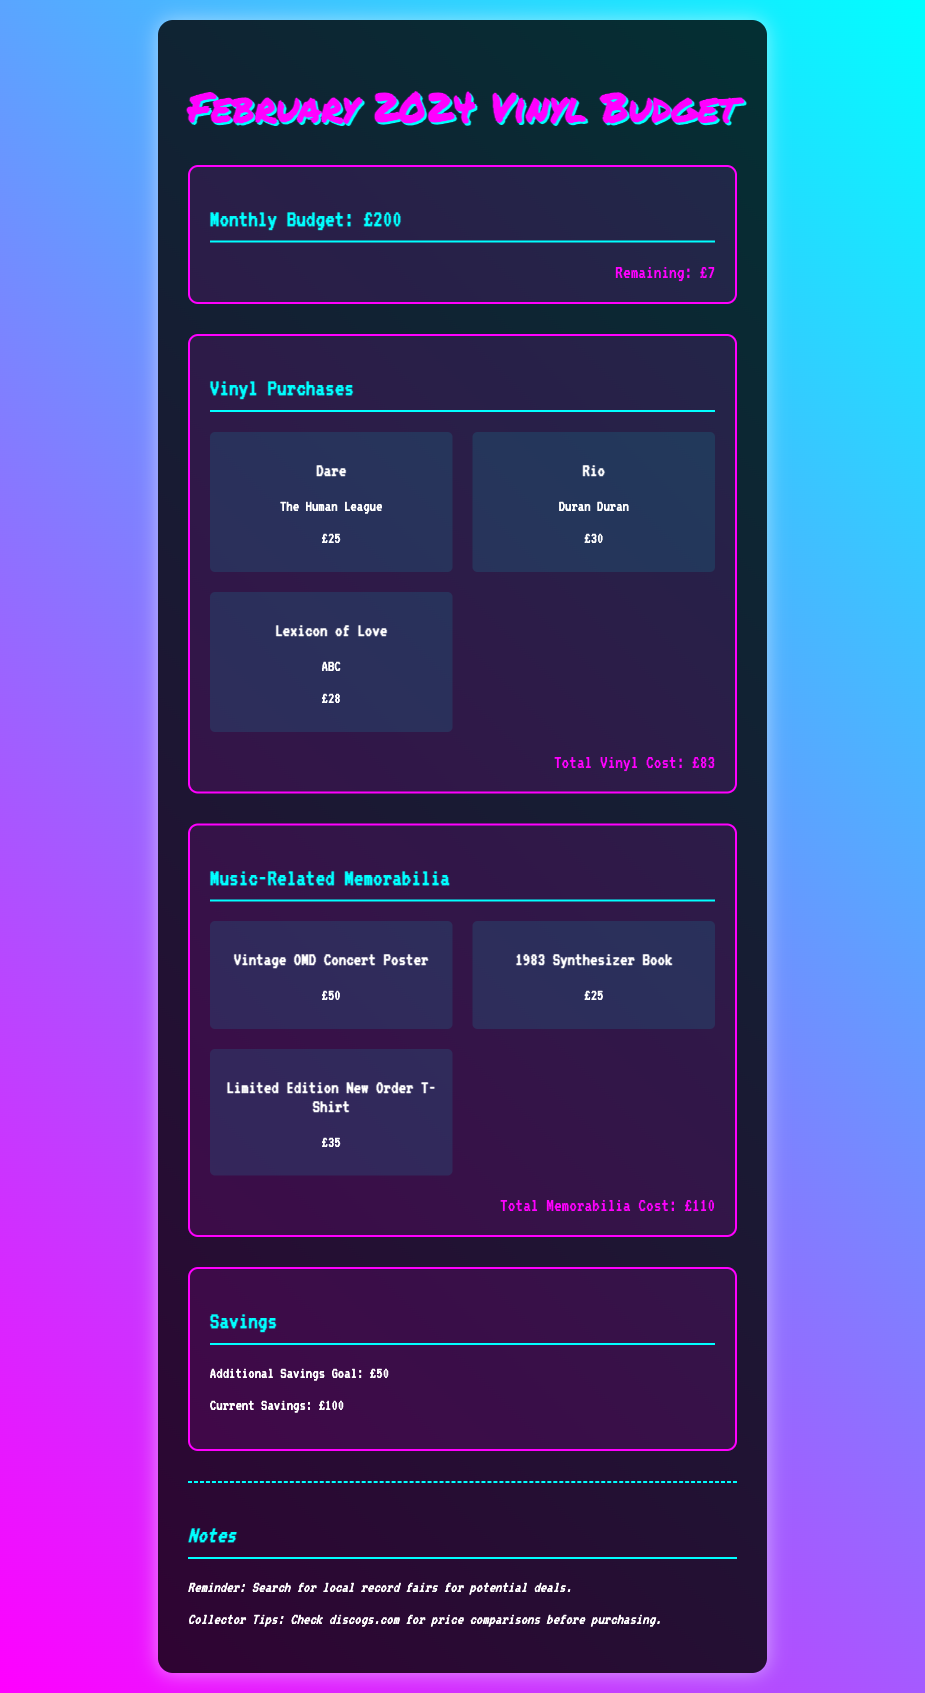What is the monthly budget? The monthly budget is stated directly in the document as £200.
Answer: £200 What is the total cost of vinyl purchases? The total cost of vinyl purchases is summarized at the end of the vinyl section, which amounts to £83.
Answer: £83 How much is the current savings? The current savings are explicitly listed in the document as £100.
Answer: £100 What is the remaining budget after expenditures? The remaining budget is stated at the end of the monthly budget section, which is £7.
Answer: £7 What is the price of the Limited Edition New Order T-Shirt? The price for this specific memorabilia item is listed as £35.
Answer: £35 Which vinyl album has the highest cost? The album with the highest cost among the vinyl purchases is "Rio" priced at £30.
Answer: Rio What is the total cost of music-related memorabilia? The total cost of music-related memorabilia is highlighted at the end of that section, which amounts to £110.
Answer: £110 What is the additional savings goal? The additional savings goal is mentioned in the savings section of the document as £50.
Answer: £50 What reminder is included in the notes? The document includes a reminder to search for local record fairs for potential deals.
Answer: Search for local record fairs for potential deals 